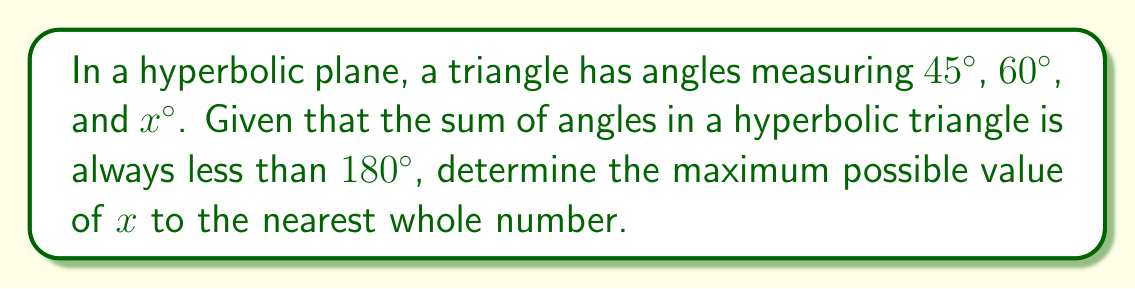Can you answer this question? Let's approach this step-by-step:

1) In Euclidean geometry, we know that the sum of angles in a triangle is always $180°$. However, in hyperbolic geometry, this sum is always less than $180°$.

2) Let's denote the sum of angles in our hyperbolic triangle as $S$. We know:

   $S = 45° + 60° + x° < 180°$

3) Simplifying:

   $105° + x° < 180°$

4) Subtracting $105°$ from both sides:

   $x° < 75°$

5) Since we're asked for the maximum possible value of $x$, we want the largest whole number that satisfies this inequality.

6) The largest whole number less than $75$ is $74$.

Therefore, the maximum possible value of $x$, to the nearest whole number, is $74°$.

[asy]
import geometry;

size(200);

pair A = (0,0), B = (2,0), C = (1,1.5);

draw(A--B--C--cycle);

label("45°", A, SW);
label("60°", B, SE);
label("$x°$", C, N);

dot(A); dot(B); dot(C);
[/asy]
Answer: $74°$ 